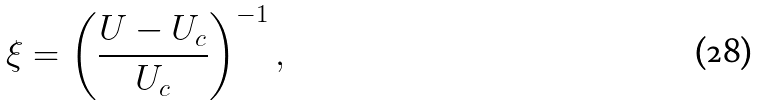<formula> <loc_0><loc_0><loc_500><loc_500>\xi = \left ( \frac { U - U _ { c } } { U _ { c } } \right ) ^ { - 1 } ,</formula> 